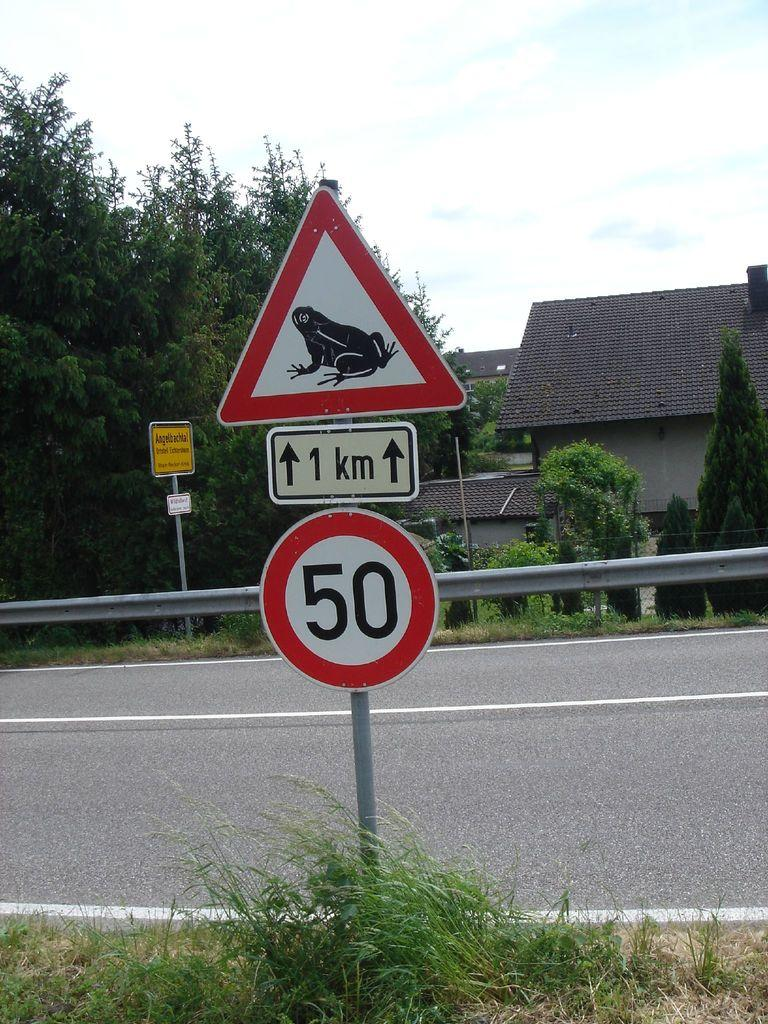<image>
Give a short and clear explanation of the subsequent image. A red and white sign with a frog on it is on the side of the road and there is another sign beneath that says 50. 